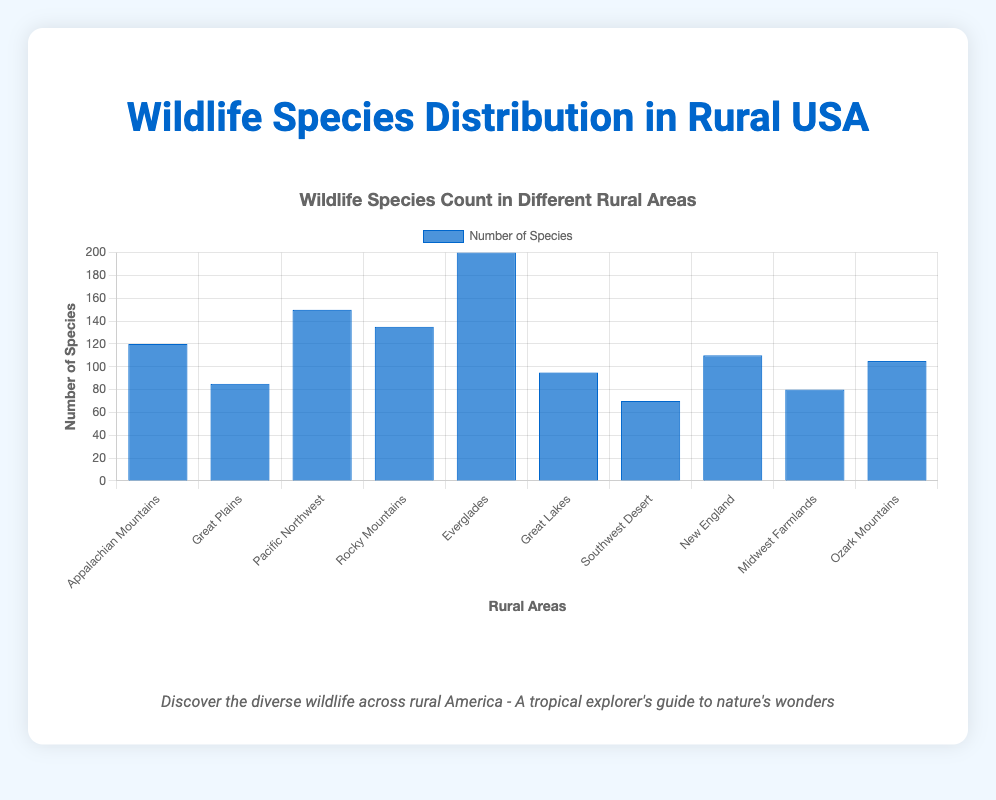Which rural area has the highest number of wildlife species? The height of the bar representing the Everglades is the tallest among all, indicating it has the highest species count.
Answer: Everglades Which area has fewer species, the Great Lakes or the Great Plains? Comparing the bars for the Great Lakes and the Great Plains, the Great Plains has a bar with 85 species, while the Great Lakes has a bar with 95 species. Thus, the Great Plains has fewer species.
Answer: Great Plains What's the difference in the number of species between the Pacific Northwest and the Appalachian Mountains? The Pacific Northwest has a species count of 150, and the Appalachian Mountains have 120 species. The difference is 150 - 120.
Answer: 30 Identify the areas with a species count above 100. The bars that reach past the 100 species mark belong to the Appalachian Mountains (120), Pacific Northwest (150), Rocky Mountains (135), Everglades (200), New England (110), and Ozark Mountains (105).
Answer: Appalachian Mountains, Pacific Northwest, Rocky Mountains, Everglades, New England, Ozark Mountains What is the sum of species in the Great Plains and the Midwest Farmlands? The bars for the Great Plains and the Midwest Farmlands indicate species counts of 85 and 80, respectively. The sum is 85 + 80.
Answer: 165 Which rural area has the second highest number of wildlife species? The Everglades have the highest count (200), followed by the Pacific Northwest, which has the next tallest bar with 150 species.
Answer: Pacific Northwest Is the number of species in the Rocky Mountains greater than that in the New England area? The Rocky Mountains have a species count of 135, while New England has 110 species. 135 is greater than 110.
Answer: Yes What is the average number of species across all areas? Adding up all species counts (120 + 85 + 150 + 135 + 200 + 95 + 70 + 110 + 80 + 105) equals 1150. Dividing the sum by the number of areas (10) gives us the average: 1150/10.
Answer: 115 What's the combined species count for the Rocky Mountains, Pacific Northwest, and Southwest Desert? The species counts for these areas are 135, 150, and 70 respectively. Summing them up gives: 135 + 150 + 70.
Answer: 355 